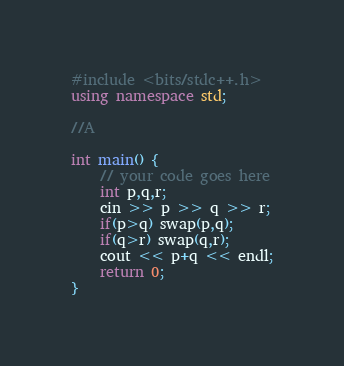<code> <loc_0><loc_0><loc_500><loc_500><_C++_>#include <bits/stdc++.h>
using namespace std;

//A

int main() {
	// your code goes here
	int p,q,r;
	cin >> p >> q >> r;
	if(p>q) swap(p,q);
	if(q>r) swap(q,r);
	cout << p+q << endl;
	return 0;
}</code> 